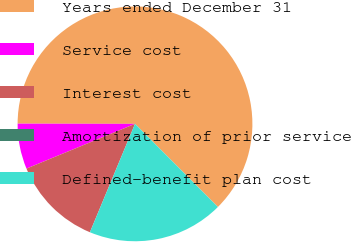Convert chart to OTSL. <chart><loc_0><loc_0><loc_500><loc_500><pie_chart><fcel>Years ended December 31<fcel>Service cost<fcel>Interest cost<fcel>Amortization of prior service<fcel>Defined-benefit plan cost<nl><fcel>62.49%<fcel>6.25%<fcel>12.5%<fcel>0.0%<fcel>18.75%<nl></chart> 